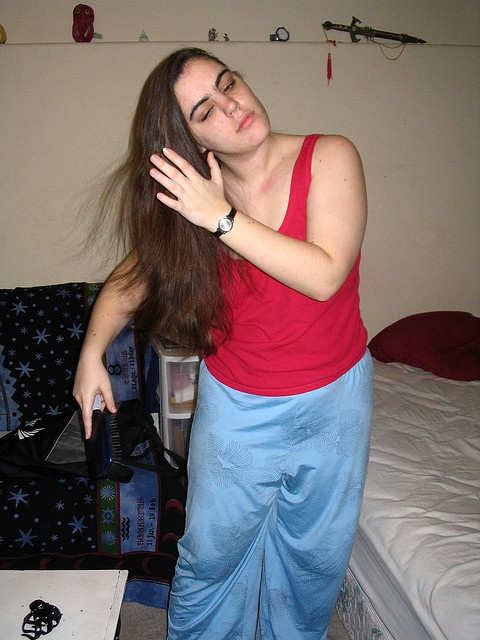Describe the objects in this image and their specific colors. I can see people in gray, tan, lightblue, and black tones, couch in gray, black, navy, and darkblue tones, and bed in gray, darkgray, and black tones in this image. 